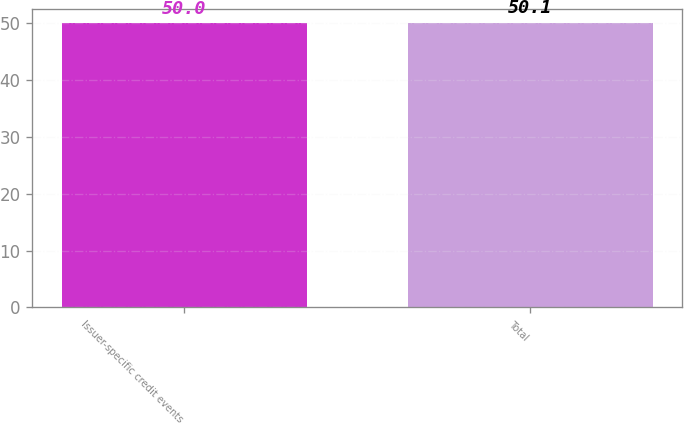Convert chart to OTSL. <chart><loc_0><loc_0><loc_500><loc_500><bar_chart><fcel>Issuer-specific credit events<fcel>Total<nl><fcel>50<fcel>50.1<nl></chart> 